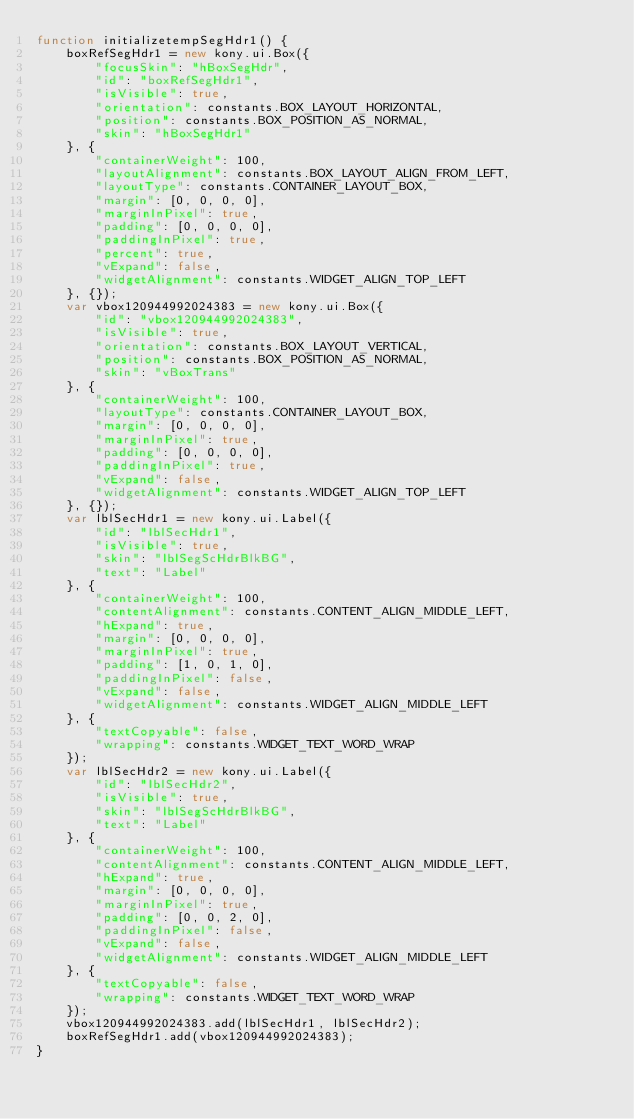<code> <loc_0><loc_0><loc_500><loc_500><_JavaScript_>function initializetempSegHdr1() {
    boxRefSegHdr1 = new kony.ui.Box({
        "focusSkin": "hBoxSegHdr",
        "id": "boxRefSegHdr1",
        "isVisible": true,
        "orientation": constants.BOX_LAYOUT_HORIZONTAL,
        "position": constants.BOX_POSITION_AS_NORMAL,
        "skin": "hBoxSegHdr1"
    }, {
        "containerWeight": 100,
        "layoutAlignment": constants.BOX_LAYOUT_ALIGN_FROM_LEFT,
        "layoutType": constants.CONTAINER_LAYOUT_BOX,
        "margin": [0, 0, 0, 0],
        "marginInPixel": true,
        "padding": [0, 0, 0, 0],
        "paddingInPixel": true,
        "percent": true,
        "vExpand": false,
        "widgetAlignment": constants.WIDGET_ALIGN_TOP_LEFT
    }, {});
    var vbox120944992024383 = new kony.ui.Box({
        "id": "vbox120944992024383",
        "isVisible": true,
        "orientation": constants.BOX_LAYOUT_VERTICAL,
        "position": constants.BOX_POSITION_AS_NORMAL,
        "skin": "vBoxTrans"
    }, {
        "containerWeight": 100,
        "layoutType": constants.CONTAINER_LAYOUT_BOX,
        "margin": [0, 0, 0, 0],
        "marginInPixel": true,
        "padding": [0, 0, 0, 0],
        "paddingInPixel": true,
        "vExpand": false,
        "widgetAlignment": constants.WIDGET_ALIGN_TOP_LEFT
    }, {});
    var lblSecHdr1 = new kony.ui.Label({
        "id": "lblSecHdr1",
        "isVisible": true,
        "skin": "lblSegScHdrBlkBG",
        "text": "Label"
    }, {
        "containerWeight": 100,
        "contentAlignment": constants.CONTENT_ALIGN_MIDDLE_LEFT,
        "hExpand": true,
        "margin": [0, 0, 0, 0],
        "marginInPixel": true,
        "padding": [1, 0, 1, 0],
        "paddingInPixel": false,
        "vExpand": false,
        "widgetAlignment": constants.WIDGET_ALIGN_MIDDLE_LEFT
    }, {
        "textCopyable": false,
        "wrapping": constants.WIDGET_TEXT_WORD_WRAP
    });
    var lblSecHdr2 = new kony.ui.Label({
        "id": "lblSecHdr2",
        "isVisible": true,
        "skin": "lblSegScHdrBlkBG",
        "text": "Label"
    }, {
        "containerWeight": 100,
        "contentAlignment": constants.CONTENT_ALIGN_MIDDLE_LEFT,
        "hExpand": true,
        "margin": [0, 0, 0, 0],
        "marginInPixel": true,
        "padding": [0, 0, 2, 0],
        "paddingInPixel": false,
        "vExpand": false,
        "widgetAlignment": constants.WIDGET_ALIGN_MIDDLE_LEFT
    }, {
        "textCopyable": false,
        "wrapping": constants.WIDGET_TEXT_WORD_WRAP
    });
    vbox120944992024383.add(lblSecHdr1, lblSecHdr2);
    boxRefSegHdr1.add(vbox120944992024383);
}</code> 